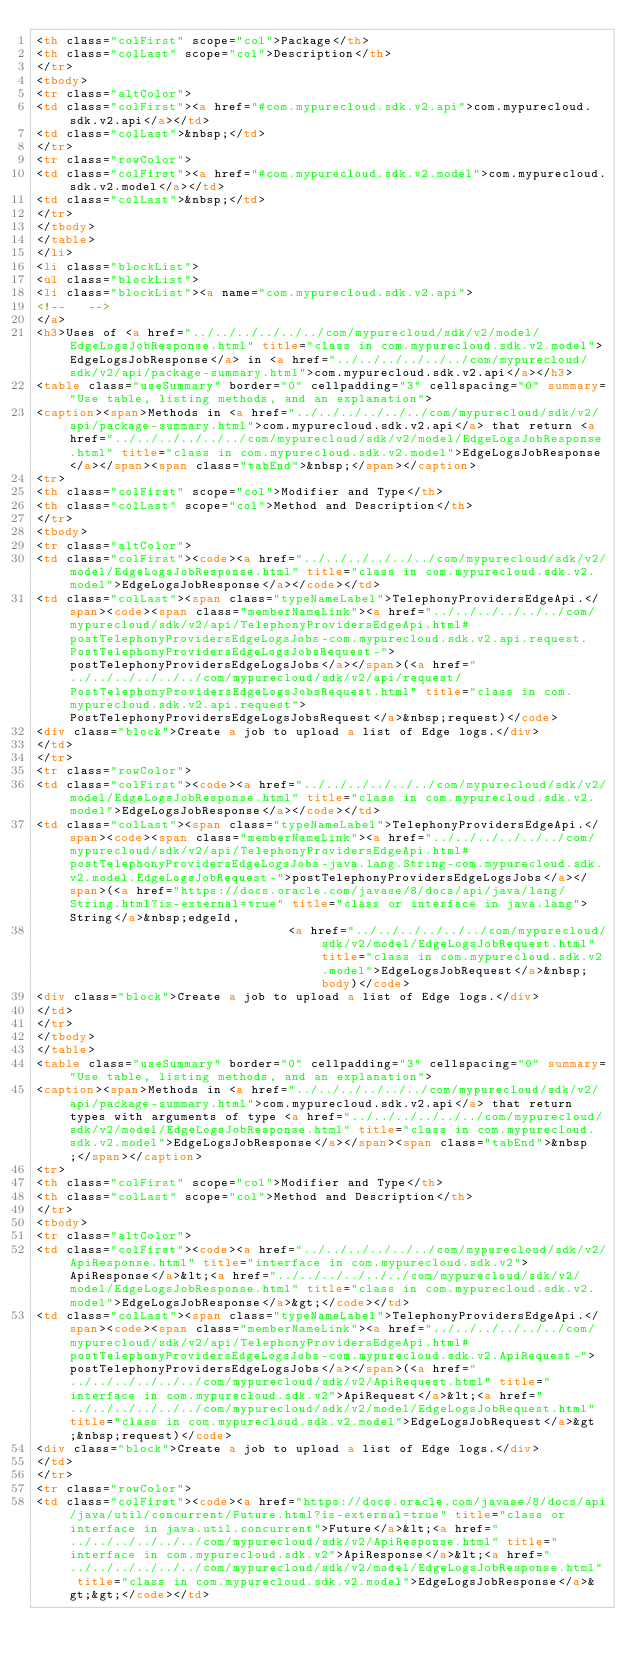<code> <loc_0><loc_0><loc_500><loc_500><_HTML_><th class="colFirst" scope="col">Package</th>
<th class="colLast" scope="col">Description</th>
</tr>
<tbody>
<tr class="altColor">
<td class="colFirst"><a href="#com.mypurecloud.sdk.v2.api">com.mypurecloud.sdk.v2.api</a></td>
<td class="colLast">&nbsp;</td>
</tr>
<tr class="rowColor">
<td class="colFirst"><a href="#com.mypurecloud.sdk.v2.model">com.mypurecloud.sdk.v2.model</a></td>
<td class="colLast">&nbsp;</td>
</tr>
</tbody>
</table>
</li>
<li class="blockList">
<ul class="blockList">
<li class="blockList"><a name="com.mypurecloud.sdk.v2.api">
<!--   -->
</a>
<h3>Uses of <a href="../../../../../../com/mypurecloud/sdk/v2/model/EdgeLogsJobResponse.html" title="class in com.mypurecloud.sdk.v2.model">EdgeLogsJobResponse</a> in <a href="../../../../../../com/mypurecloud/sdk/v2/api/package-summary.html">com.mypurecloud.sdk.v2.api</a></h3>
<table class="useSummary" border="0" cellpadding="3" cellspacing="0" summary="Use table, listing methods, and an explanation">
<caption><span>Methods in <a href="../../../../../../com/mypurecloud/sdk/v2/api/package-summary.html">com.mypurecloud.sdk.v2.api</a> that return <a href="../../../../../../com/mypurecloud/sdk/v2/model/EdgeLogsJobResponse.html" title="class in com.mypurecloud.sdk.v2.model">EdgeLogsJobResponse</a></span><span class="tabEnd">&nbsp;</span></caption>
<tr>
<th class="colFirst" scope="col">Modifier and Type</th>
<th class="colLast" scope="col">Method and Description</th>
</tr>
<tbody>
<tr class="altColor">
<td class="colFirst"><code><a href="../../../../../../com/mypurecloud/sdk/v2/model/EdgeLogsJobResponse.html" title="class in com.mypurecloud.sdk.v2.model">EdgeLogsJobResponse</a></code></td>
<td class="colLast"><span class="typeNameLabel">TelephonyProvidersEdgeApi.</span><code><span class="memberNameLink"><a href="../../../../../../com/mypurecloud/sdk/v2/api/TelephonyProvidersEdgeApi.html#postTelephonyProvidersEdgeLogsJobs-com.mypurecloud.sdk.v2.api.request.PostTelephonyProvidersEdgeLogsJobsRequest-">postTelephonyProvidersEdgeLogsJobs</a></span>(<a href="../../../../../../com/mypurecloud/sdk/v2/api/request/PostTelephonyProvidersEdgeLogsJobsRequest.html" title="class in com.mypurecloud.sdk.v2.api.request">PostTelephonyProvidersEdgeLogsJobsRequest</a>&nbsp;request)</code>
<div class="block">Create a job to upload a list of Edge logs.</div>
</td>
</tr>
<tr class="rowColor">
<td class="colFirst"><code><a href="../../../../../../com/mypurecloud/sdk/v2/model/EdgeLogsJobResponse.html" title="class in com.mypurecloud.sdk.v2.model">EdgeLogsJobResponse</a></code></td>
<td class="colLast"><span class="typeNameLabel">TelephonyProvidersEdgeApi.</span><code><span class="memberNameLink"><a href="../../../../../../com/mypurecloud/sdk/v2/api/TelephonyProvidersEdgeApi.html#postTelephonyProvidersEdgeLogsJobs-java.lang.String-com.mypurecloud.sdk.v2.model.EdgeLogsJobRequest-">postTelephonyProvidersEdgeLogsJobs</a></span>(<a href="https://docs.oracle.com/javase/8/docs/api/java/lang/String.html?is-external=true" title="class or interface in java.lang">String</a>&nbsp;edgeId,
                                  <a href="../../../../../../com/mypurecloud/sdk/v2/model/EdgeLogsJobRequest.html" title="class in com.mypurecloud.sdk.v2.model">EdgeLogsJobRequest</a>&nbsp;body)</code>
<div class="block">Create a job to upload a list of Edge logs.</div>
</td>
</tr>
</tbody>
</table>
<table class="useSummary" border="0" cellpadding="3" cellspacing="0" summary="Use table, listing methods, and an explanation">
<caption><span>Methods in <a href="../../../../../../com/mypurecloud/sdk/v2/api/package-summary.html">com.mypurecloud.sdk.v2.api</a> that return types with arguments of type <a href="../../../../../../com/mypurecloud/sdk/v2/model/EdgeLogsJobResponse.html" title="class in com.mypurecloud.sdk.v2.model">EdgeLogsJobResponse</a></span><span class="tabEnd">&nbsp;</span></caption>
<tr>
<th class="colFirst" scope="col">Modifier and Type</th>
<th class="colLast" scope="col">Method and Description</th>
</tr>
<tbody>
<tr class="altColor">
<td class="colFirst"><code><a href="../../../../../../com/mypurecloud/sdk/v2/ApiResponse.html" title="interface in com.mypurecloud.sdk.v2">ApiResponse</a>&lt;<a href="../../../../../../com/mypurecloud/sdk/v2/model/EdgeLogsJobResponse.html" title="class in com.mypurecloud.sdk.v2.model">EdgeLogsJobResponse</a>&gt;</code></td>
<td class="colLast"><span class="typeNameLabel">TelephonyProvidersEdgeApi.</span><code><span class="memberNameLink"><a href="../../../../../../com/mypurecloud/sdk/v2/api/TelephonyProvidersEdgeApi.html#postTelephonyProvidersEdgeLogsJobs-com.mypurecloud.sdk.v2.ApiRequest-">postTelephonyProvidersEdgeLogsJobs</a></span>(<a href="../../../../../../com/mypurecloud/sdk/v2/ApiRequest.html" title="interface in com.mypurecloud.sdk.v2">ApiRequest</a>&lt;<a href="../../../../../../com/mypurecloud/sdk/v2/model/EdgeLogsJobRequest.html" title="class in com.mypurecloud.sdk.v2.model">EdgeLogsJobRequest</a>&gt;&nbsp;request)</code>
<div class="block">Create a job to upload a list of Edge logs.</div>
</td>
</tr>
<tr class="rowColor">
<td class="colFirst"><code><a href="https://docs.oracle.com/javase/8/docs/api/java/util/concurrent/Future.html?is-external=true" title="class or interface in java.util.concurrent">Future</a>&lt;<a href="../../../../../../com/mypurecloud/sdk/v2/ApiResponse.html" title="interface in com.mypurecloud.sdk.v2">ApiResponse</a>&lt;<a href="../../../../../../com/mypurecloud/sdk/v2/model/EdgeLogsJobResponse.html" title="class in com.mypurecloud.sdk.v2.model">EdgeLogsJobResponse</a>&gt;&gt;</code></td></code> 